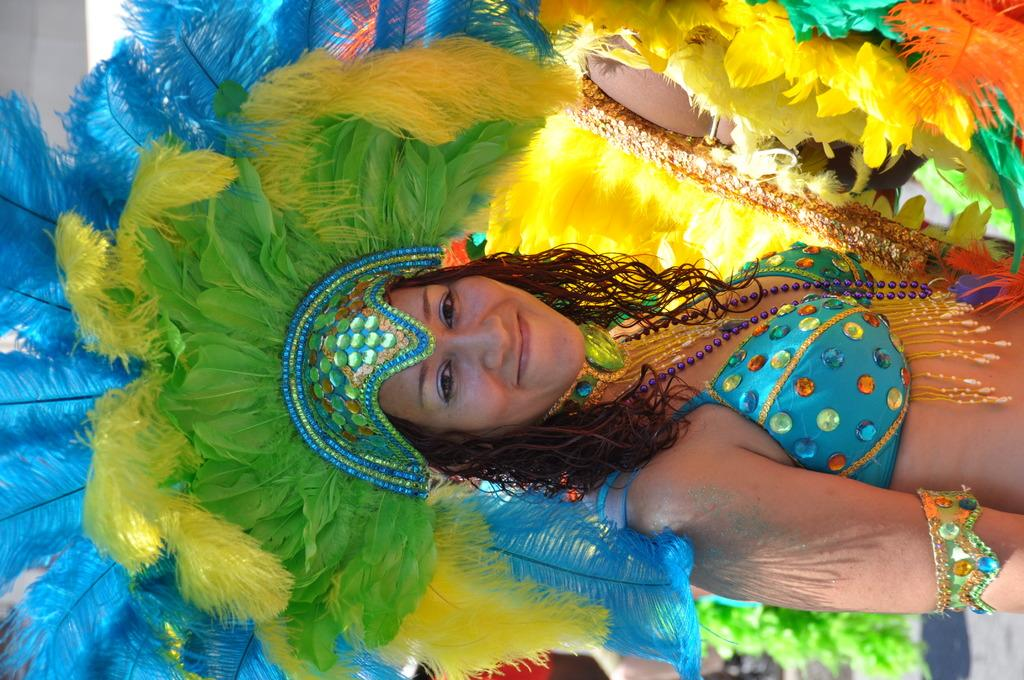Who is present in the image? There is a woman in the image. What is the woman wearing? The woman is wearing a fancy dress. What expression does the woman have? The woman is smiling. What type of cable can be seen in the woman's vein in the image? There is no cable or vein visible in the image; it only features a woman wearing a fancy clothing and smiling. 